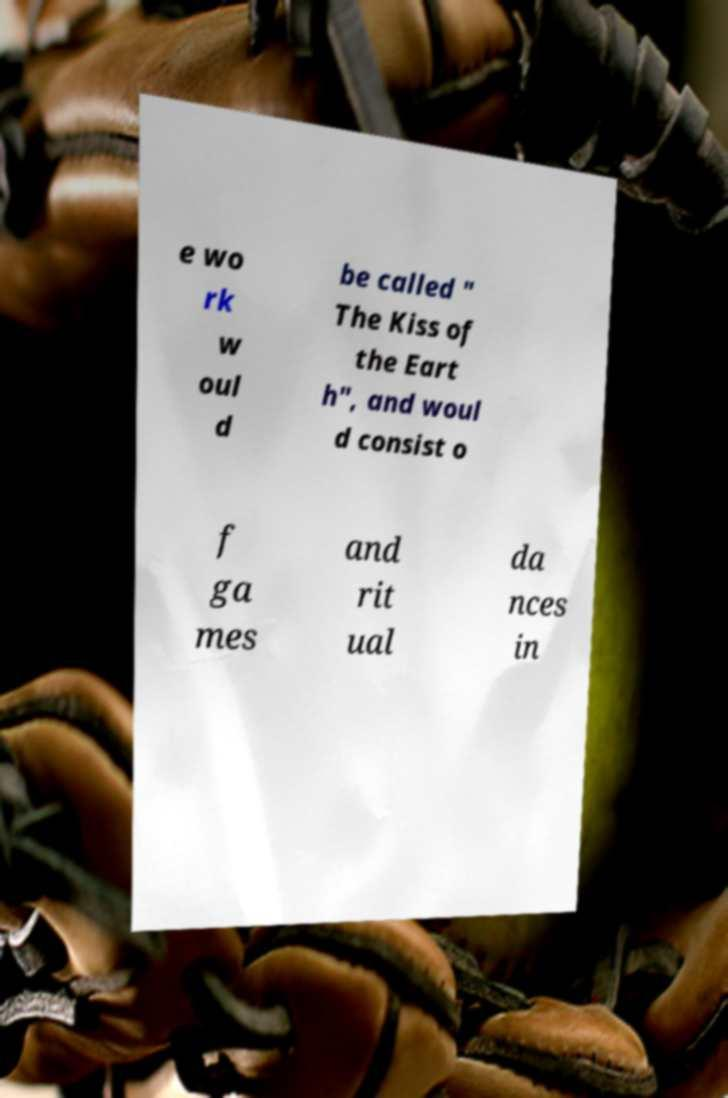Can you accurately transcribe the text from the provided image for me? e wo rk w oul d be called " The Kiss of the Eart h", and woul d consist o f ga mes and rit ual da nces in 